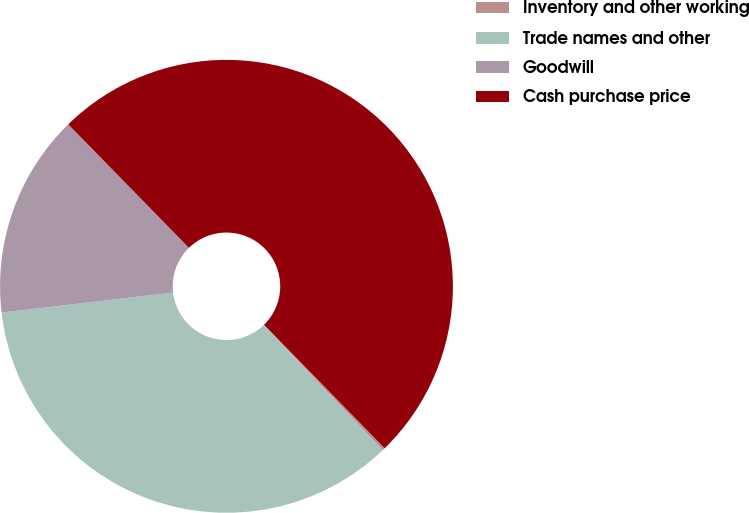Convert chart to OTSL. <chart><loc_0><loc_0><loc_500><loc_500><pie_chart><fcel>Inventory and other working<fcel>Trade names and other<fcel>Goodwill<fcel>Cash purchase price<nl><fcel>0.19%<fcel>35.27%<fcel>14.54%<fcel>50.0%<nl></chart> 